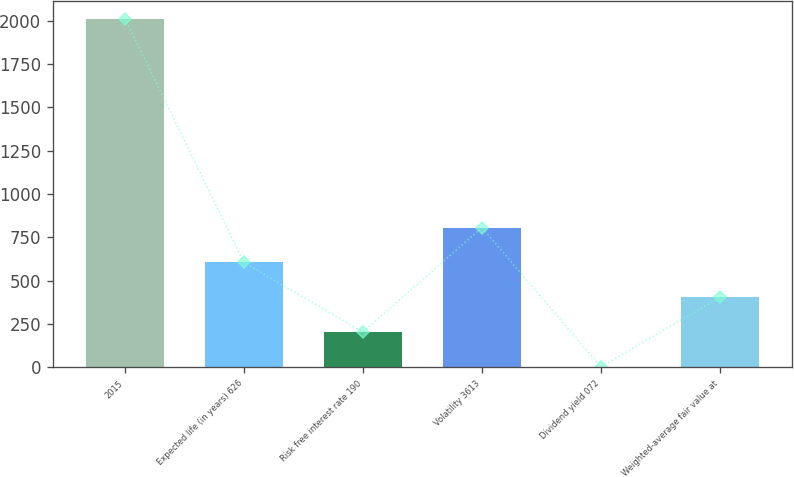<chart> <loc_0><loc_0><loc_500><loc_500><bar_chart><fcel>2015<fcel>Expected life (in years) 626<fcel>Risk free interest rate 190<fcel>Volatility 3613<fcel>Dividend yield 072<fcel>Weighted-average fair value at<nl><fcel>2013<fcel>604.65<fcel>202.27<fcel>805.84<fcel>1.08<fcel>403.46<nl></chart> 